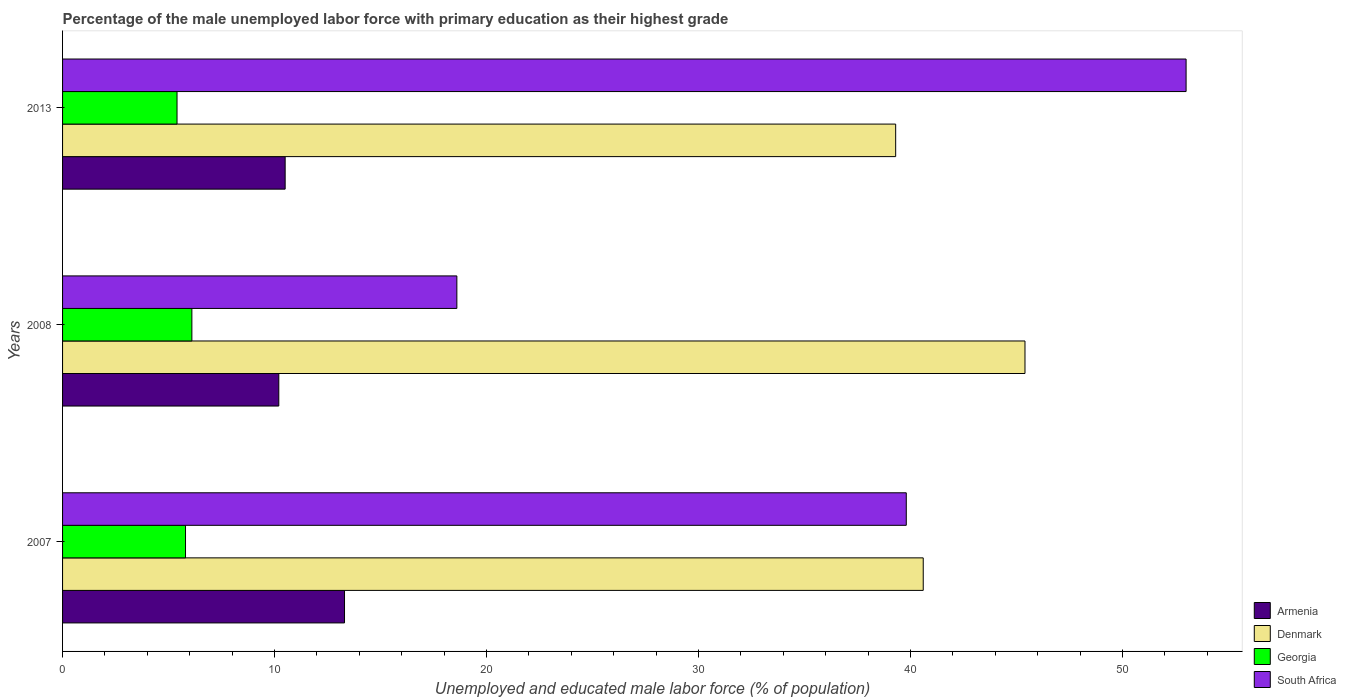Are the number of bars on each tick of the Y-axis equal?
Make the answer very short. Yes. How many bars are there on the 1st tick from the top?
Make the answer very short. 4. In how many cases, is the number of bars for a given year not equal to the number of legend labels?
Offer a terse response. 0. What is the percentage of the unemployed male labor force with primary education in Armenia in 2007?
Your answer should be compact. 13.3. Across all years, what is the maximum percentage of the unemployed male labor force with primary education in Armenia?
Your answer should be compact. 13.3. Across all years, what is the minimum percentage of the unemployed male labor force with primary education in Georgia?
Your response must be concise. 5.4. What is the difference between the percentage of the unemployed male labor force with primary education in Georgia in 2007 and that in 2013?
Provide a succinct answer. 0.4. What is the difference between the percentage of the unemployed male labor force with primary education in Armenia in 2008 and the percentage of the unemployed male labor force with primary education in Denmark in 2013?
Offer a very short reply. -29.1. What is the average percentage of the unemployed male labor force with primary education in Denmark per year?
Keep it short and to the point. 41.77. In the year 2007, what is the difference between the percentage of the unemployed male labor force with primary education in South Africa and percentage of the unemployed male labor force with primary education in Denmark?
Make the answer very short. -0.8. In how many years, is the percentage of the unemployed male labor force with primary education in Denmark greater than 52 %?
Offer a terse response. 0. What is the ratio of the percentage of the unemployed male labor force with primary education in South Africa in 2007 to that in 2008?
Offer a terse response. 2.14. Is the percentage of the unemployed male labor force with primary education in South Africa in 2008 less than that in 2013?
Keep it short and to the point. Yes. Is the difference between the percentage of the unemployed male labor force with primary education in South Africa in 2008 and 2013 greater than the difference between the percentage of the unemployed male labor force with primary education in Denmark in 2008 and 2013?
Make the answer very short. No. What is the difference between the highest and the second highest percentage of the unemployed male labor force with primary education in South Africa?
Provide a succinct answer. 13.2. What is the difference between the highest and the lowest percentage of the unemployed male labor force with primary education in Armenia?
Your response must be concise. 3.1. Is it the case that in every year, the sum of the percentage of the unemployed male labor force with primary education in Georgia and percentage of the unemployed male labor force with primary education in Armenia is greater than the sum of percentage of the unemployed male labor force with primary education in South Africa and percentage of the unemployed male labor force with primary education in Denmark?
Your answer should be very brief. No. What does the 1st bar from the top in 2013 represents?
Give a very brief answer. South Africa. What does the 3rd bar from the bottom in 2007 represents?
Provide a short and direct response. Georgia. How many bars are there?
Provide a succinct answer. 12. Are all the bars in the graph horizontal?
Ensure brevity in your answer.  Yes. How many years are there in the graph?
Provide a succinct answer. 3. Are the values on the major ticks of X-axis written in scientific E-notation?
Offer a terse response. No. What is the title of the graph?
Offer a terse response. Percentage of the male unemployed labor force with primary education as their highest grade. Does "South Africa" appear as one of the legend labels in the graph?
Your answer should be compact. Yes. What is the label or title of the X-axis?
Make the answer very short. Unemployed and educated male labor force (% of population). What is the Unemployed and educated male labor force (% of population) in Armenia in 2007?
Provide a succinct answer. 13.3. What is the Unemployed and educated male labor force (% of population) in Denmark in 2007?
Provide a succinct answer. 40.6. What is the Unemployed and educated male labor force (% of population) in Georgia in 2007?
Provide a succinct answer. 5.8. What is the Unemployed and educated male labor force (% of population) in South Africa in 2007?
Make the answer very short. 39.8. What is the Unemployed and educated male labor force (% of population) in Armenia in 2008?
Offer a very short reply. 10.2. What is the Unemployed and educated male labor force (% of population) in Denmark in 2008?
Offer a terse response. 45.4. What is the Unemployed and educated male labor force (% of population) in Georgia in 2008?
Your answer should be very brief. 6.1. What is the Unemployed and educated male labor force (% of population) in South Africa in 2008?
Your response must be concise. 18.6. What is the Unemployed and educated male labor force (% of population) of Denmark in 2013?
Keep it short and to the point. 39.3. What is the Unemployed and educated male labor force (% of population) of Georgia in 2013?
Offer a very short reply. 5.4. What is the Unemployed and educated male labor force (% of population) of South Africa in 2013?
Offer a very short reply. 53. Across all years, what is the maximum Unemployed and educated male labor force (% of population) in Armenia?
Offer a very short reply. 13.3. Across all years, what is the maximum Unemployed and educated male labor force (% of population) of Denmark?
Ensure brevity in your answer.  45.4. Across all years, what is the maximum Unemployed and educated male labor force (% of population) in Georgia?
Offer a terse response. 6.1. Across all years, what is the maximum Unemployed and educated male labor force (% of population) in South Africa?
Keep it short and to the point. 53. Across all years, what is the minimum Unemployed and educated male labor force (% of population) in Armenia?
Provide a short and direct response. 10.2. Across all years, what is the minimum Unemployed and educated male labor force (% of population) of Denmark?
Make the answer very short. 39.3. Across all years, what is the minimum Unemployed and educated male labor force (% of population) in Georgia?
Provide a short and direct response. 5.4. Across all years, what is the minimum Unemployed and educated male labor force (% of population) in South Africa?
Keep it short and to the point. 18.6. What is the total Unemployed and educated male labor force (% of population) in Denmark in the graph?
Make the answer very short. 125.3. What is the total Unemployed and educated male labor force (% of population) of Georgia in the graph?
Give a very brief answer. 17.3. What is the total Unemployed and educated male labor force (% of population) of South Africa in the graph?
Keep it short and to the point. 111.4. What is the difference between the Unemployed and educated male labor force (% of population) in Denmark in 2007 and that in 2008?
Your response must be concise. -4.8. What is the difference between the Unemployed and educated male labor force (% of population) of South Africa in 2007 and that in 2008?
Your answer should be compact. 21.2. What is the difference between the Unemployed and educated male labor force (% of population) in Denmark in 2007 and that in 2013?
Provide a succinct answer. 1.3. What is the difference between the Unemployed and educated male labor force (% of population) in Georgia in 2007 and that in 2013?
Offer a very short reply. 0.4. What is the difference between the Unemployed and educated male labor force (% of population) of South Africa in 2007 and that in 2013?
Make the answer very short. -13.2. What is the difference between the Unemployed and educated male labor force (% of population) in Denmark in 2008 and that in 2013?
Your answer should be very brief. 6.1. What is the difference between the Unemployed and educated male labor force (% of population) in Georgia in 2008 and that in 2013?
Your answer should be very brief. 0.7. What is the difference between the Unemployed and educated male labor force (% of population) of South Africa in 2008 and that in 2013?
Keep it short and to the point. -34.4. What is the difference between the Unemployed and educated male labor force (% of population) in Armenia in 2007 and the Unemployed and educated male labor force (% of population) in Denmark in 2008?
Offer a very short reply. -32.1. What is the difference between the Unemployed and educated male labor force (% of population) of Armenia in 2007 and the Unemployed and educated male labor force (% of population) of Georgia in 2008?
Your response must be concise. 7.2. What is the difference between the Unemployed and educated male labor force (% of population) of Armenia in 2007 and the Unemployed and educated male labor force (% of population) of South Africa in 2008?
Provide a short and direct response. -5.3. What is the difference between the Unemployed and educated male labor force (% of population) of Denmark in 2007 and the Unemployed and educated male labor force (% of population) of Georgia in 2008?
Your response must be concise. 34.5. What is the difference between the Unemployed and educated male labor force (% of population) of Denmark in 2007 and the Unemployed and educated male labor force (% of population) of South Africa in 2008?
Ensure brevity in your answer.  22. What is the difference between the Unemployed and educated male labor force (% of population) of Georgia in 2007 and the Unemployed and educated male labor force (% of population) of South Africa in 2008?
Offer a very short reply. -12.8. What is the difference between the Unemployed and educated male labor force (% of population) in Armenia in 2007 and the Unemployed and educated male labor force (% of population) in South Africa in 2013?
Ensure brevity in your answer.  -39.7. What is the difference between the Unemployed and educated male labor force (% of population) of Denmark in 2007 and the Unemployed and educated male labor force (% of population) of Georgia in 2013?
Offer a terse response. 35.2. What is the difference between the Unemployed and educated male labor force (% of population) in Denmark in 2007 and the Unemployed and educated male labor force (% of population) in South Africa in 2013?
Your answer should be compact. -12.4. What is the difference between the Unemployed and educated male labor force (% of population) of Georgia in 2007 and the Unemployed and educated male labor force (% of population) of South Africa in 2013?
Your answer should be very brief. -47.2. What is the difference between the Unemployed and educated male labor force (% of population) of Armenia in 2008 and the Unemployed and educated male labor force (% of population) of Denmark in 2013?
Your response must be concise. -29.1. What is the difference between the Unemployed and educated male labor force (% of population) of Armenia in 2008 and the Unemployed and educated male labor force (% of population) of Georgia in 2013?
Make the answer very short. 4.8. What is the difference between the Unemployed and educated male labor force (% of population) in Armenia in 2008 and the Unemployed and educated male labor force (% of population) in South Africa in 2013?
Provide a short and direct response. -42.8. What is the difference between the Unemployed and educated male labor force (% of population) in Georgia in 2008 and the Unemployed and educated male labor force (% of population) in South Africa in 2013?
Make the answer very short. -46.9. What is the average Unemployed and educated male labor force (% of population) of Armenia per year?
Your response must be concise. 11.33. What is the average Unemployed and educated male labor force (% of population) in Denmark per year?
Your answer should be very brief. 41.77. What is the average Unemployed and educated male labor force (% of population) in Georgia per year?
Provide a succinct answer. 5.77. What is the average Unemployed and educated male labor force (% of population) of South Africa per year?
Your answer should be compact. 37.13. In the year 2007, what is the difference between the Unemployed and educated male labor force (% of population) in Armenia and Unemployed and educated male labor force (% of population) in Denmark?
Your response must be concise. -27.3. In the year 2007, what is the difference between the Unemployed and educated male labor force (% of population) of Armenia and Unemployed and educated male labor force (% of population) of Georgia?
Make the answer very short. 7.5. In the year 2007, what is the difference between the Unemployed and educated male labor force (% of population) in Armenia and Unemployed and educated male labor force (% of population) in South Africa?
Offer a very short reply. -26.5. In the year 2007, what is the difference between the Unemployed and educated male labor force (% of population) in Denmark and Unemployed and educated male labor force (% of population) in Georgia?
Your answer should be very brief. 34.8. In the year 2007, what is the difference between the Unemployed and educated male labor force (% of population) in Denmark and Unemployed and educated male labor force (% of population) in South Africa?
Give a very brief answer. 0.8. In the year 2007, what is the difference between the Unemployed and educated male labor force (% of population) in Georgia and Unemployed and educated male labor force (% of population) in South Africa?
Provide a succinct answer. -34. In the year 2008, what is the difference between the Unemployed and educated male labor force (% of population) in Armenia and Unemployed and educated male labor force (% of population) in Denmark?
Give a very brief answer. -35.2. In the year 2008, what is the difference between the Unemployed and educated male labor force (% of population) in Denmark and Unemployed and educated male labor force (% of population) in Georgia?
Ensure brevity in your answer.  39.3. In the year 2008, what is the difference between the Unemployed and educated male labor force (% of population) of Denmark and Unemployed and educated male labor force (% of population) of South Africa?
Offer a terse response. 26.8. In the year 2008, what is the difference between the Unemployed and educated male labor force (% of population) of Georgia and Unemployed and educated male labor force (% of population) of South Africa?
Your response must be concise. -12.5. In the year 2013, what is the difference between the Unemployed and educated male labor force (% of population) in Armenia and Unemployed and educated male labor force (% of population) in Denmark?
Offer a terse response. -28.8. In the year 2013, what is the difference between the Unemployed and educated male labor force (% of population) of Armenia and Unemployed and educated male labor force (% of population) of South Africa?
Ensure brevity in your answer.  -42.5. In the year 2013, what is the difference between the Unemployed and educated male labor force (% of population) of Denmark and Unemployed and educated male labor force (% of population) of Georgia?
Your answer should be very brief. 33.9. In the year 2013, what is the difference between the Unemployed and educated male labor force (% of population) in Denmark and Unemployed and educated male labor force (% of population) in South Africa?
Your response must be concise. -13.7. In the year 2013, what is the difference between the Unemployed and educated male labor force (% of population) of Georgia and Unemployed and educated male labor force (% of population) of South Africa?
Your answer should be compact. -47.6. What is the ratio of the Unemployed and educated male labor force (% of population) in Armenia in 2007 to that in 2008?
Give a very brief answer. 1.3. What is the ratio of the Unemployed and educated male labor force (% of population) in Denmark in 2007 to that in 2008?
Make the answer very short. 0.89. What is the ratio of the Unemployed and educated male labor force (% of population) in Georgia in 2007 to that in 2008?
Provide a succinct answer. 0.95. What is the ratio of the Unemployed and educated male labor force (% of population) in South Africa in 2007 to that in 2008?
Make the answer very short. 2.14. What is the ratio of the Unemployed and educated male labor force (% of population) of Armenia in 2007 to that in 2013?
Offer a terse response. 1.27. What is the ratio of the Unemployed and educated male labor force (% of population) of Denmark in 2007 to that in 2013?
Provide a short and direct response. 1.03. What is the ratio of the Unemployed and educated male labor force (% of population) of Georgia in 2007 to that in 2013?
Provide a succinct answer. 1.07. What is the ratio of the Unemployed and educated male labor force (% of population) of South Africa in 2007 to that in 2013?
Ensure brevity in your answer.  0.75. What is the ratio of the Unemployed and educated male labor force (% of population) in Armenia in 2008 to that in 2013?
Keep it short and to the point. 0.97. What is the ratio of the Unemployed and educated male labor force (% of population) of Denmark in 2008 to that in 2013?
Your answer should be very brief. 1.16. What is the ratio of the Unemployed and educated male labor force (% of population) of Georgia in 2008 to that in 2013?
Your response must be concise. 1.13. What is the ratio of the Unemployed and educated male labor force (% of population) in South Africa in 2008 to that in 2013?
Your response must be concise. 0.35. What is the difference between the highest and the second highest Unemployed and educated male labor force (% of population) of Denmark?
Your answer should be compact. 4.8. What is the difference between the highest and the lowest Unemployed and educated male labor force (% of population) in Denmark?
Provide a short and direct response. 6.1. What is the difference between the highest and the lowest Unemployed and educated male labor force (% of population) in South Africa?
Make the answer very short. 34.4. 